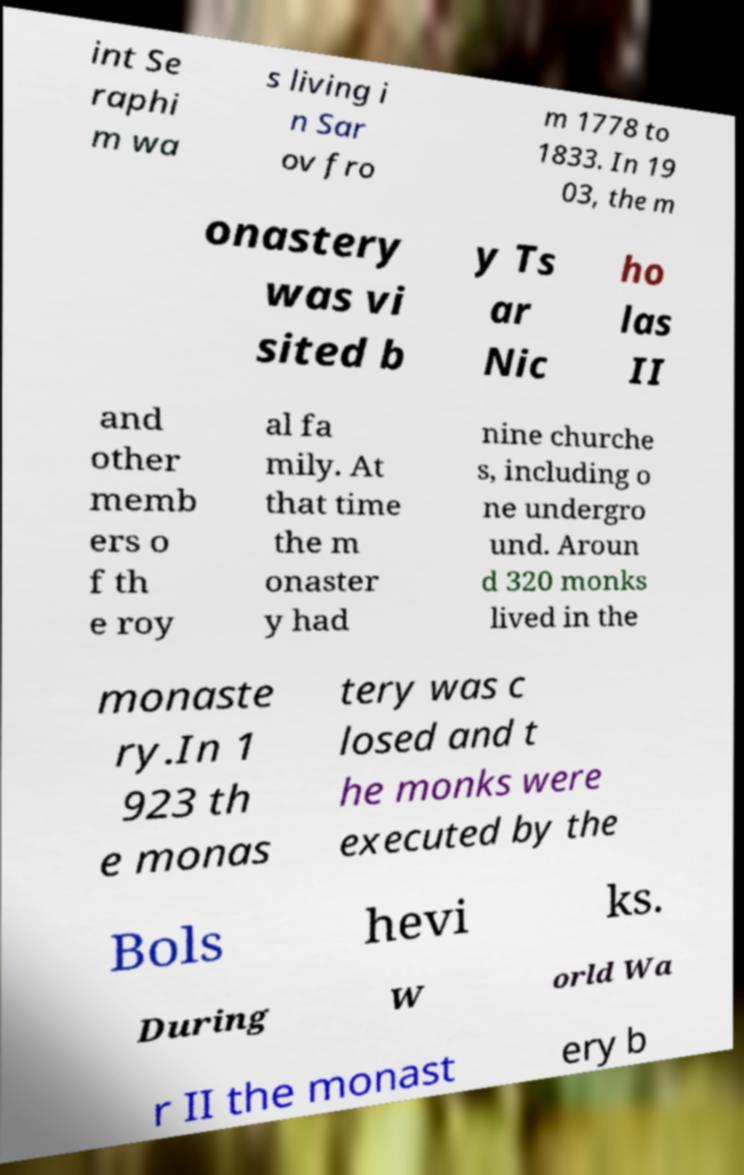There's text embedded in this image that I need extracted. Can you transcribe it verbatim? int Se raphi m wa s living i n Sar ov fro m 1778 to 1833. In 19 03, the m onastery was vi sited b y Ts ar Nic ho las II and other memb ers o f th e roy al fa mily. At that time the m onaster y had nine churche s, including o ne undergro und. Aroun d 320 monks lived in the monaste ry.In 1 923 th e monas tery was c losed and t he monks were executed by the Bols hevi ks. During W orld Wa r II the monast ery b 